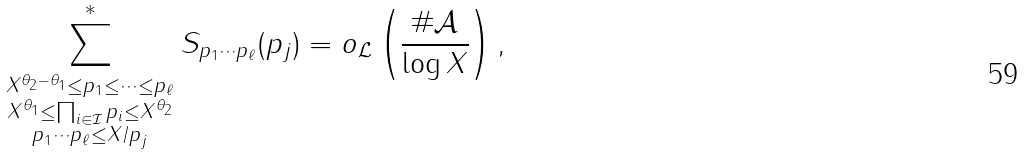<formula> <loc_0><loc_0><loc_500><loc_500>\sum _ { \substack { X ^ { \theta _ { 2 } - \theta _ { 1 } } \leq p _ { 1 } \leq \dots \leq p _ { \ell } \\ X ^ { \theta _ { 1 } } \leq \prod _ { i \in \mathcal { I } } p _ { i } \leq X ^ { \theta _ { 2 } } \\ p _ { 1 } \cdots p _ { \ell } \leq X / p _ { j } } } ^ { * } S _ { p _ { 1 } \cdots p _ { \ell } } ( p _ { j } ) = o _ { \mathcal { L } } \left ( \frac { \# \mathcal { A } } { \log { X } } \right ) ,</formula> 